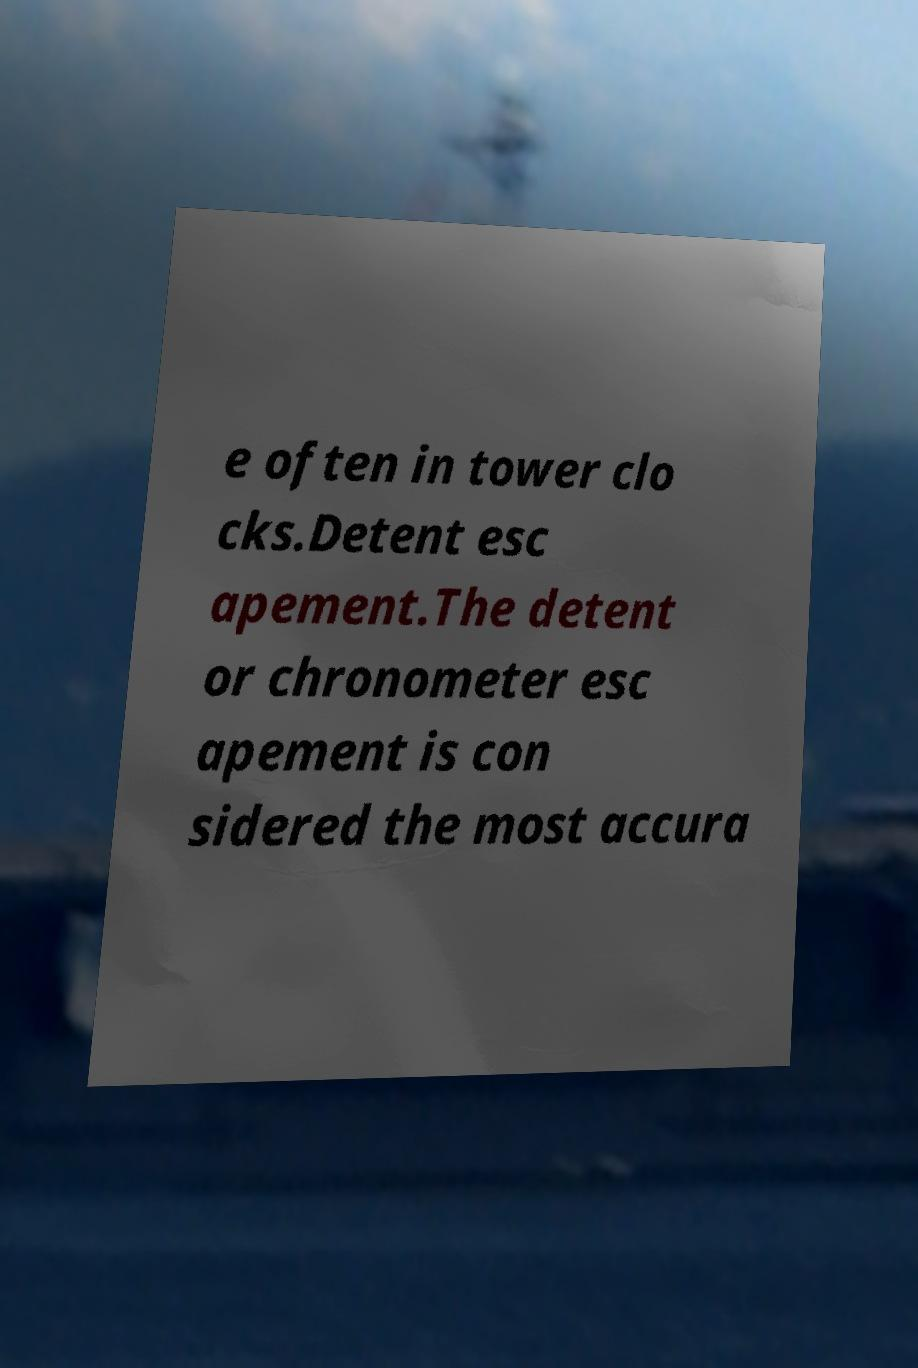Can you accurately transcribe the text from the provided image for me? e often in tower clo cks.Detent esc apement.The detent or chronometer esc apement is con sidered the most accura 